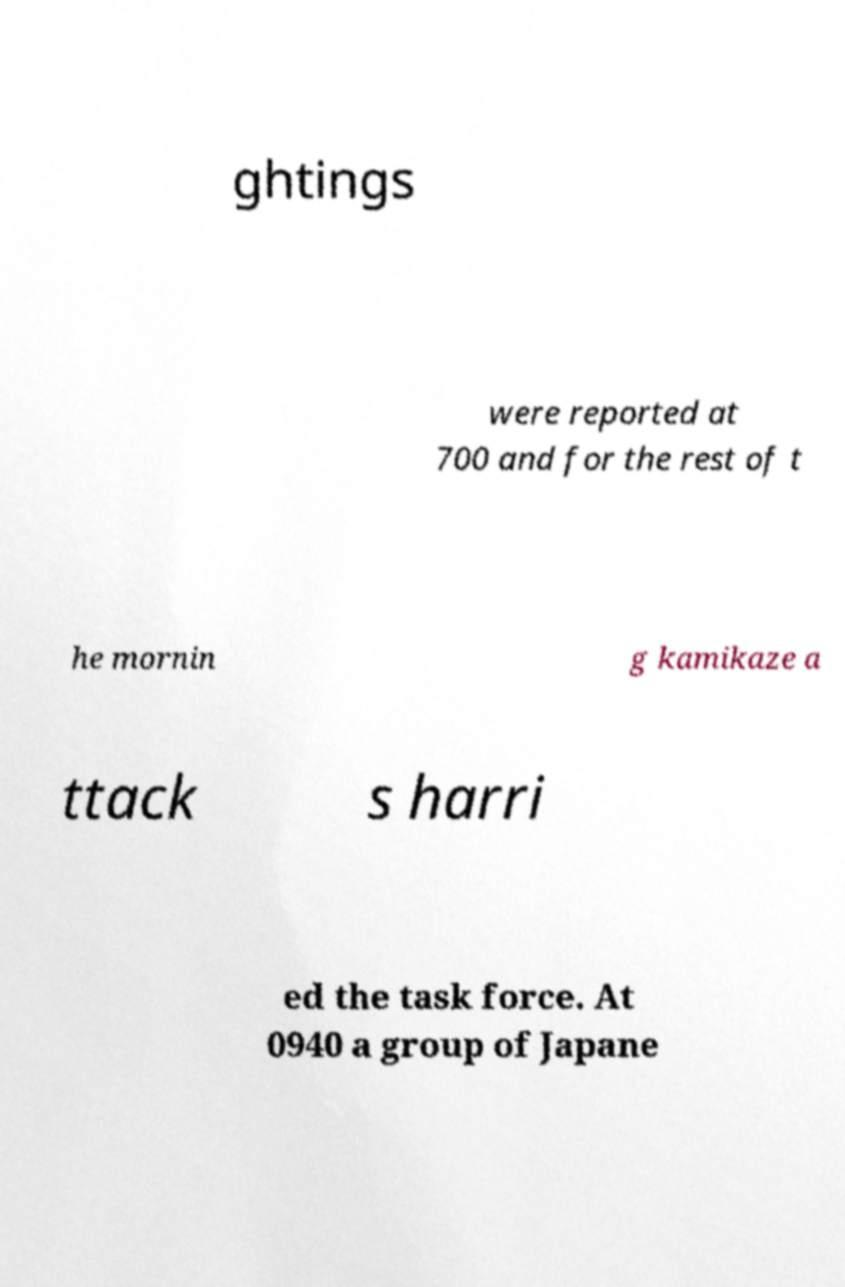Please read and relay the text visible in this image. What does it say? ghtings were reported at 700 and for the rest of t he mornin g kamikaze a ttack s harri ed the task force. At 0940 a group of Japane 